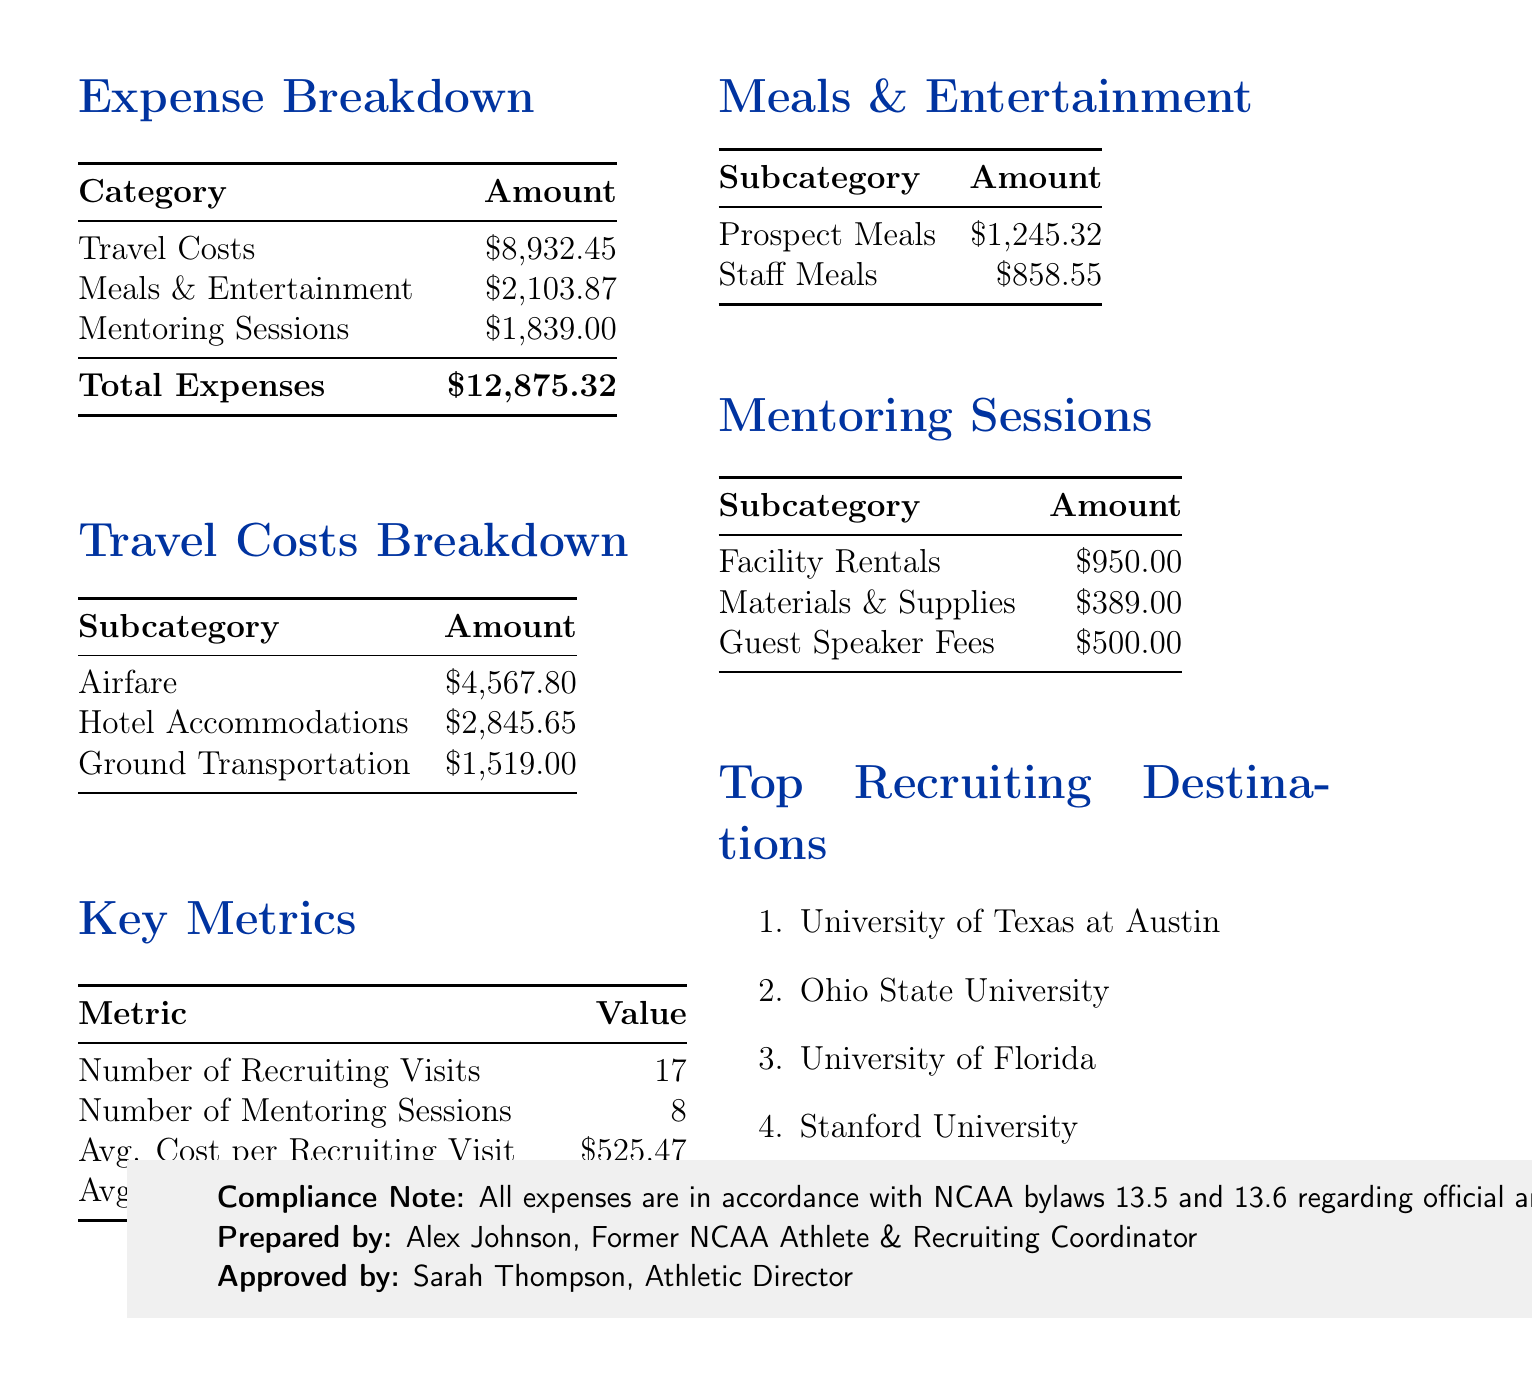what is the total expense for Q3 2023? The total expense is stated in the summary section of the report as the cumulative amount for the quarter.
Answer: $12,875.32 how much was spent on airfare? The airfare cost is provided in the breakdown of travel costs as a specific subcategory amount.
Answer: $4,567.80 how many mentoring sessions were held? The number of mentoring sessions is listed under key metrics, summarizing the total conducted in the quarter.
Answer: 8 what is the average cost per recruiting visit? The average cost per recruiting visit is calculated from the total travel expenses and the number of visits, presented in the key metrics section.
Answer: $525.47 which university was the top recruiting destination? The top recruiting destination is listed under a specific section that enumerates the destinations for recruiting visits.
Answer: University of Texas at Austin what were the total travel costs? The total travel costs are provided in the summary, indicating the cumulative expenses for travel associated with recruitment and mentoring during the quarter.
Answer: $8,932.45 what percentage of total expenses were spent on meals and entertainment? The calculation requires comparing the meals and entertainment expenses against total expenses, as shown in the breakdown.
Answer: 16.3% who prepared the report? The preparer's name is indicated at the bottom of the document, identifying who compiled the financial summary.
Answer: Alex Johnson, Former NCAA Athlete & Recruiting Coordinator 